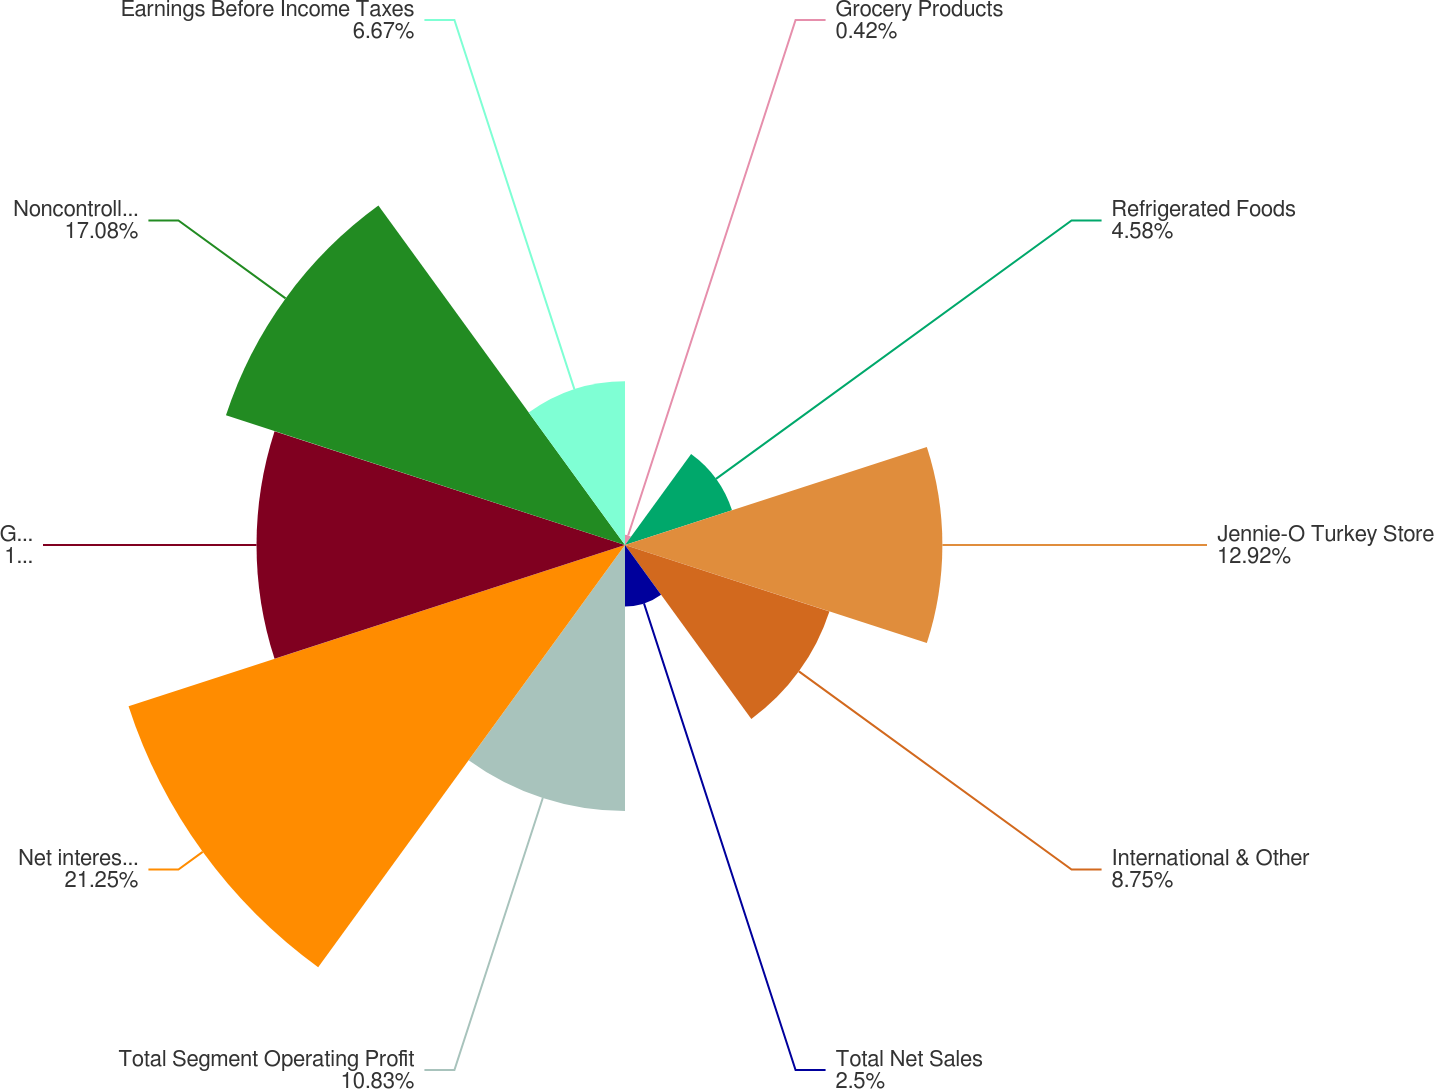<chart> <loc_0><loc_0><loc_500><loc_500><pie_chart><fcel>Grocery Products<fcel>Refrigerated Foods<fcel>Jennie-O Turkey Store<fcel>International & Other<fcel>Total Net Sales<fcel>Total Segment Operating Profit<fcel>Net interest and investment<fcel>General corporate expense<fcel>Noncontrolling interest<fcel>Earnings Before Income Taxes<nl><fcel>0.42%<fcel>4.58%<fcel>12.92%<fcel>8.75%<fcel>2.5%<fcel>10.83%<fcel>21.25%<fcel>15.0%<fcel>17.08%<fcel>6.67%<nl></chart> 